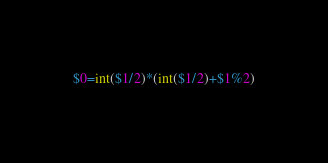<code> <loc_0><loc_0><loc_500><loc_500><_Awk_>$0=int($1/2)*(int($1/2)+$1%2)</code> 